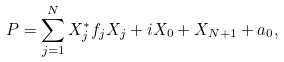Convert formula to latex. <formula><loc_0><loc_0><loc_500><loc_500>P = \sum _ { j = 1 } ^ { N } X _ { j } ^ { * } f _ { j } X _ { j } + i X _ { 0 } + X _ { N + 1 } + a _ { 0 } ,</formula> 